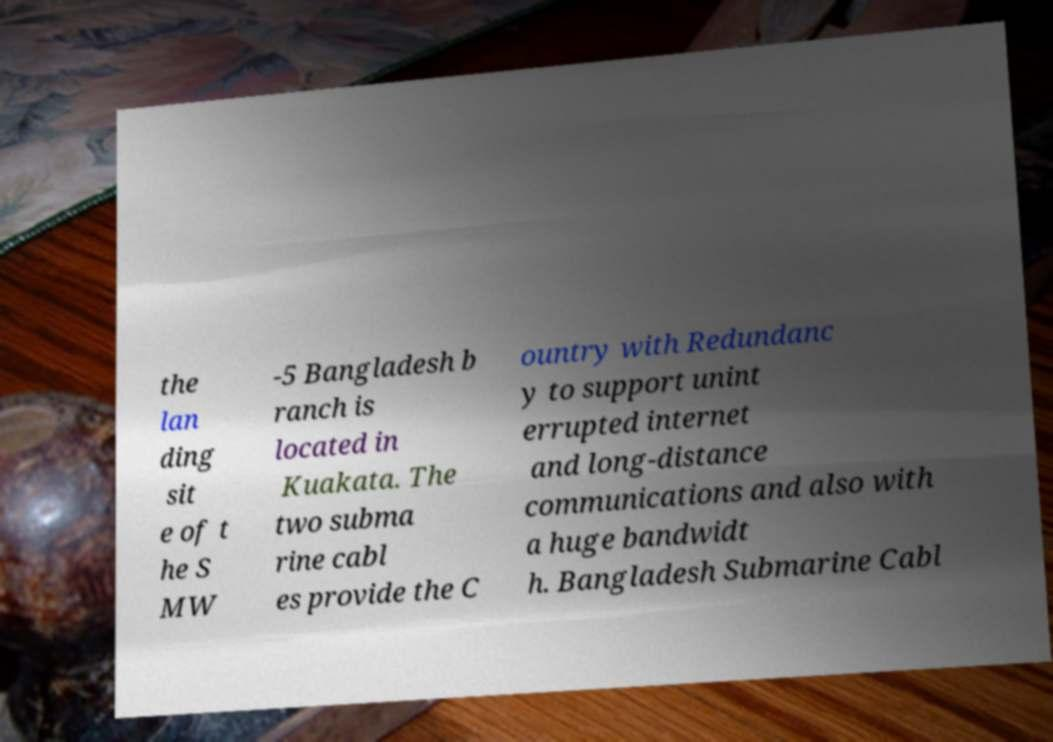I need the written content from this picture converted into text. Can you do that? the lan ding sit e of t he S MW -5 Bangladesh b ranch is located in Kuakata. The two subma rine cabl es provide the C ountry with Redundanc y to support unint errupted internet and long-distance communications and also with a huge bandwidt h. Bangladesh Submarine Cabl 